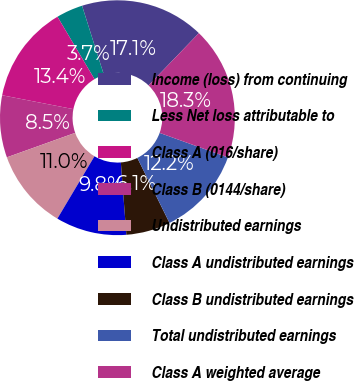Convert chart to OTSL. <chart><loc_0><loc_0><loc_500><loc_500><pie_chart><fcel>Income (loss) from continuing<fcel>Less Net loss attributable to<fcel>Class A (016/share)<fcel>Class B (0144/share)<fcel>Undistributed earnings<fcel>Class A undistributed earnings<fcel>Class B undistributed earnings<fcel>Total undistributed earnings<fcel>Class A weighted average<nl><fcel>17.07%<fcel>3.66%<fcel>13.41%<fcel>8.54%<fcel>10.98%<fcel>9.76%<fcel>6.1%<fcel>12.19%<fcel>18.29%<nl></chart> 